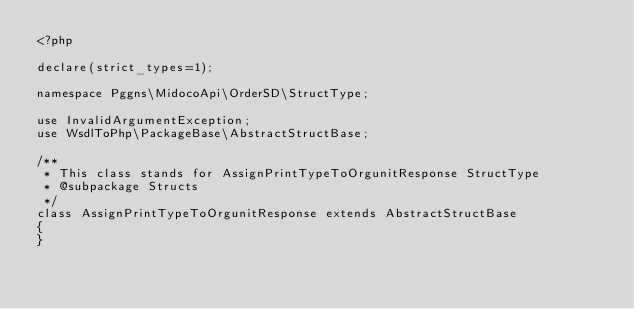<code> <loc_0><loc_0><loc_500><loc_500><_PHP_><?php

declare(strict_types=1);

namespace Pggns\MidocoApi\OrderSD\StructType;

use InvalidArgumentException;
use WsdlToPhp\PackageBase\AbstractStructBase;

/**
 * This class stands for AssignPrintTypeToOrgunitResponse StructType
 * @subpackage Structs
 */
class AssignPrintTypeToOrgunitResponse extends AbstractStructBase
{
}
</code> 